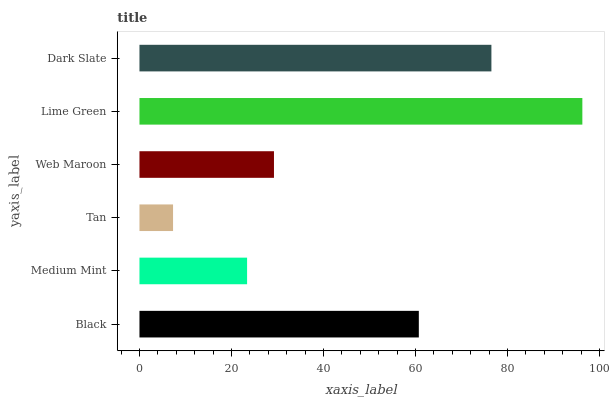Is Tan the minimum?
Answer yes or no. Yes. Is Lime Green the maximum?
Answer yes or no. Yes. Is Medium Mint the minimum?
Answer yes or no. No. Is Medium Mint the maximum?
Answer yes or no. No. Is Black greater than Medium Mint?
Answer yes or no. Yes. Is Medium Mint less than Black?
Answer yes or no. Yes. Is Medium Mint greater than Black?
Answer yes or no. No. Is Black less than Medium Mint?
Answer yes or no. No. Is Black the high median?
Answer yes or no. Yes. Is Web Maroon the low median?
Answer yes or no. Yes. Is Tan the high median?
Answer yes or no. No. Is Medium Mint the low median?
Answer yes or no. No. 